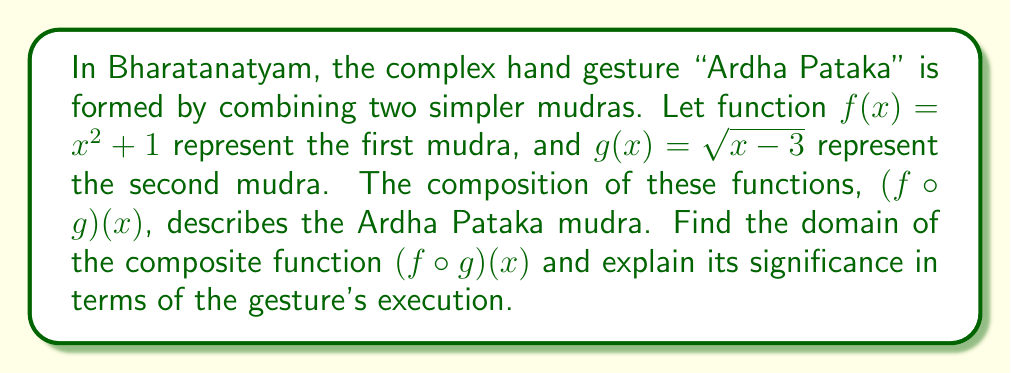Give your solution to this math problem. To find the domain of the composite function $(f \circ g)(x)$, we need to consider the restrictions on both functions and how they interact when composed.

1. First, let's consider the inner function $g(x) = \sqrt{x - 3}$:
   - The domain of $g(x)$ is restricted by the square root. We need $x - 3 \geq 0$.
   - Solving this inequality: $x \geq 3$

2. Now, let's compose $f(x)$ with $g(x)$:
   $(f \circ g)(x) = f(g(x)) = (\sqrt{x - 3})^2 + 1 = (x - 3) + 1 = x - 2$

3. The domain of $f(x) = x^2 + 1$ is all real numbers, so it doesn't add any additional restrictions.

4. Therefore, the domain of $(f \circ g)(x)$ is the same as the domain of $g(x)$: $x \geq 3$

In terms of the Ardha Pataka mudra's execution:
- The domain $x \geq 3$ represents the range of motion or positions possible for this hand gesture.
- The lower bound of 3 could symbolize the minimum extension or angle required for the fingers to form the correct shape.
- Values of $x$ greater than 3 correspond to variations or intensities of the gesture, allowing for subtle expressions in the dance.

This mathematical representation emphasizes the precision required in Bharatanatyam, where even small variations in hand positions can convey different meanings or emotions.
Answer: The domain of $(f \circ g)(x)$ is $\{x \in \mathbb{R} : x \geq 3\}$. 